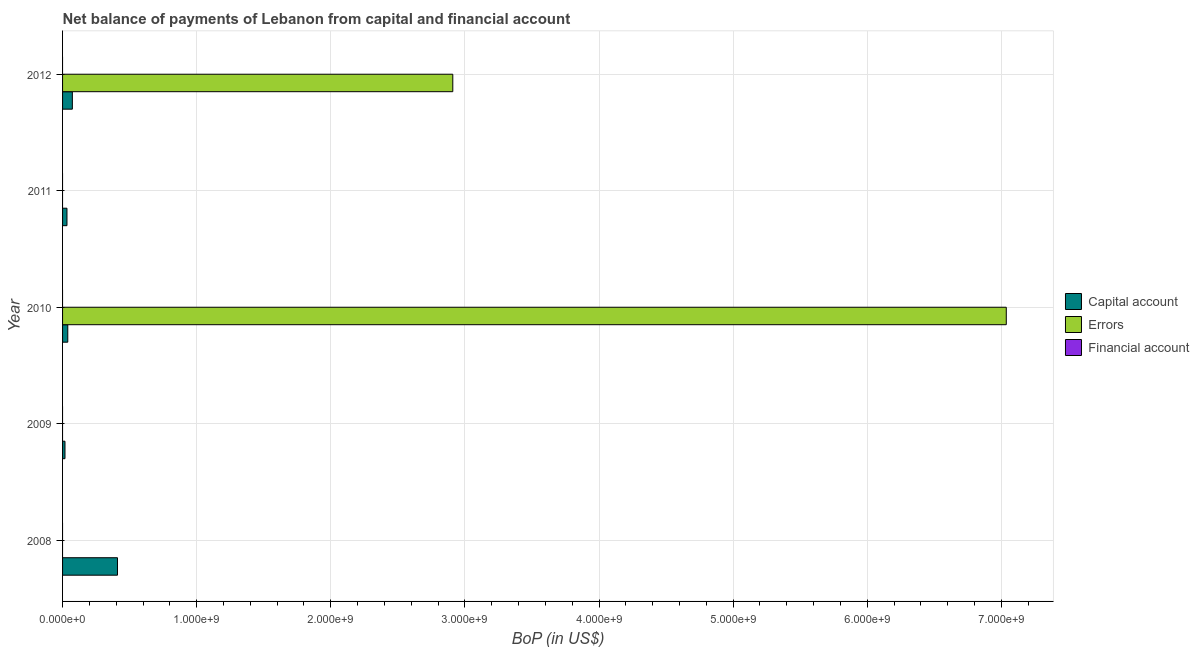Are the number of bars per tick equal to the number of legend labels?
Your answer should be very brief. No. Are the number of bars on each tick of the Y-axis equal?
Give a very brief answer. No. What is the label of the 4th group of bars from the top?
Provide a short and direct response. 2009. In how many cases, is the number of bars for a given year not equal to the number of legend labels?
Keep it short and to the point. 5. What is the amount of errors in 2011?
Offer a terse response. 0. Across all years, what is the maximum amount of net capital account?
Offer a very short reply. 4.10e+08. Across all years, what is the minimum amount of errors?
Provide a short and direct response. 0. What is the total amount of errors in the graph?
Ensure brevity in your answer.  9.95e+09. What is the difference between the amount of net capital account in 2009 and that in 2010?
Keep it short and to the point. -2.09e+07. What is the difference between the amount of errors in 2010 and the amount of financial account in 2009?
Your answer should be compact. 7.04e+09. In the year 2012, what is the difference between the amount of errors and amount of net capital account?
Keep it short and to the point. 2.84e+09. In how many years, is the amount of financial account greater than 1000000000 US$?
Ensure brevity in your answer.  0. What is the difference between the highest and the lowest amount of errors?
Make the answer very short. 7.04e+09. How many bars are there?
Your answer should be compact. 7. Are all the bars in the graph horizontal?
Give a very brief answer. Yes. How many years are there in the graph?
Your answer should be very brief. 5. Are the values on the major ticks of X-axis written in scientific E-notation?
Offer a terse response. Yes. Does the graph contain any zero values?
Ensure brevity in your answer.  Yes. How many legend labels are there?
Your answer should be compact. 3. What is the title of the graph?
Your answer should be compact. Net balance of payments of Lebanon from capital and financial account. What is the label or title of the X-axis?
Give a very brief answer. BoP (in US$). What is the label or title of the Y-axis?
Your response must be concise. Year. What is the BoP (in US$) of Capital account in 2008?
Provide a short and direct response. 4.10e+08. What is the BoP (in US$) in Errors in 2008?
Your answer should be very brief. 0. What is the BoP (in US$) in Financial account in 2008?
Make the answer very short. 0. What is the BoP (in US$) in Capital account in 2009?
Your response must be concise. 1.80e+07. What is the BoP (in US$) in Capital account in 2010?
Provide a succinct answer. 3.88e+07. What is the BoP (in US$) of Errors in 2010?
Offer a very short reply. 7.04e+09. What is the BoP (in US$) in Financial account in 2010?
Offer a terse response. 0. What is the BoP (in US$) in Capital account in 2011?
Provide a short and direct response. 3.28e+07. What is the BoP (in US$) of Errors in 2011?
Offer a terse response. 0. What is the BoP (in US$) in Financial account in 2011?
Give a very brief answer. 0. What is the BoP (in US$) in Capital account in 2012?
Your response must be concise. 7.31e+07. What is the BoP (in US$) of Errors in 2012?
Ensure brevity in your answer.  2.91e+09. What is the BoP (in US$) in Financial account in 2012?
Give a very brief answer. 0. Across all years, what is the maximum BoP (in US$) of Capital account?
Provide a succinct answer. 4.10e+08. Across all years, what is the maximum BoP (in US$) in Errors?
Your answer should be very brief. 7.04e+09. Across all years, what is the minimum BoP (in US$) of Capital account?
Keep it short and to the point. 1.80e+07. Across all years, what is the minimum BoP (in US$) in Errors?
Keep it short and to the point. 0. What is the total BoP (in US$) of Capital account in the graph?
Provide a succinct answer. 5.72e+08. What is the total BoP (in US$) in Errors in the graph?
Your response must be concise. 9.95e+09. What is the difference between the BoP (in US$) in Capital account in 2008 and that in 2009?
Make the answer very short. 3.92e+08. What is the difference between the BoP (in US$) in Capital account in 2008 and that in 2010?
Ensure brevity in your answer.  3.71e+08. What is the difference between the BoP (in US$) in Capital account in 2008 and that in 2011?
Ensure brevity in your answer.  3.77e+08. What is the difference between the BoP (in US$) in Capital account in 2008 and that in 2012?
Ensure brevity in your answer.  3.36e+08. What is the difference between the BoP (in US$) of Capital account in 2009 and that in 2010?
Provide a short and direct response. -2.09e+07. What is the difference between the BoP (in US$) of Capital account in 2009 and that in 2011?
Offer a very short reply. -1.48e+07. What is the difference between the BoP (in US$) in Capital account in 2009 and that in 2012?
Your answer should be very brief. -5.51e+07. What is the difference between the BoP (in US$) of Capital account in 2010 and that in 2011?
Provide a succinct answer. 6.05e+06. What is the difference between the BoP (in US$) in Capital account in 2010 and that in 2012?
Provide a succinct answer. -3.42e+07. What is the difference between the BoP (in US$) of Errors in 2010 and that in 2012?
Make the answer very short. 4.13e+09. What is the difference between the BoP (in US$) of Capital account in 2011 and that in 2012?
Make the answer very short. -4.03e+07. What is the difference between the BoP (in US$) of Capital account in 2008 and the BoP (in US$) of Errors in 2010?
Make the answer very short. -6.63e+09. What is the difference between the BoP (in US$) of Capital account in 2008 and the BoP (in US$) of Errors in 2012?
Your answer should be very brief. -2.50e+09. What is the difference between the BoP (in US$) in Capital account in 2009 and the BoP (in US$) in Errors in 2010?
Ensure brevity in your answer.  -7.02e+09. What is the difference between the BoP (in US$) of Capital account in 2009 and the BoP (in US$) of Errors in 2012?
Make the answer very short. -2.89e+09. What is the difference between the BoP (in US$) of Capital account in 2010 and the BoP (in US$) of Errors in 2012?
Offer a very short reply. -2.87e+09. What is the difference between the BoP (in US$) of Capital account in 2011 and the BoP (in US$) of Errors in 2012?
Your answer should be compact. -2.88e+09. What is the average BoP (in US$) of Capital account per year?
Keep it short and to the point. 1.14e+08. What is the average BoP (in US$) of Errors per year?
Ensure brevity in your answer.  1.99e+09. What is the average BoP (in US$) in Financial account per year?
Offer a terse response. 0. In the year 2010, what is the difference between the BoP (in US$) in Capital account and BoP (in US$) in Errors?
Give a very brief answer. -7.00e+09. In the year 2012, what is the difference between the BoP (in US$) of Capital account and BoP (in US$) of Errors?
Your answer should be very brief. -2.84e+09. What is the ratio of the BoP (in US$) of Capital account in 2008 to that in 2009?
Ensure brevity in your answer.  22.77. What is the ratio of the BoP (in US$) in Capital account in 2008 to that in 2010?
Give a very brief answer. 10.54. What is the ratio of the BoP (in US$) of Capital account in 2008 to that in 2011?
Provide a succinct answer. 12.49. What is the ratio of the BoP (in US$) in Capital account in 2008 to that in 2012?
Your answer should be very brief. 5.6. What is the ratio of the BoP (in US$) in Capital account in 2009 to that in 2010?
Provide a short and direct response. 0.46. What is the ratio of the BoP (in US$) of Capital account in 2009 to that in 2011?
Offer a very short reply. 0.55. What is the ratio of the BoP (in US$) in Capital account in 2009 to that in 2012?
Provide a succinct answer. 0.25. What is the ratio of the BoP (in US$) of Capital account in 2010 to that in 2011?
Your response must be concise. 1.18. What is the ratio of the BoP (in US$) of Capital account in 2010 to that in 2012?
Keep it short and to the point. 0.53. What is the ratio of the BoP (in US$) in Errors in 2010 to that in 2012?
Keep it short and to the point. 2.42. What is the ratio of the BoP (in US$) in Capital account in 2011 to that in 2012?
Your response must be concise. 0.45. What is the difference between the highest and the second highest BoP (in US$) of Capital account?
Provide a short and direct response. 3.36e+08. What is the difference between the highest and the lowest BoP (in US$) of Capital account?
Your answer should be very brief. 3.92e+08. What is the difference between the highest and the lowest BoP (in US$) in Errors?
Make the answer very short. 7.04e+09. 